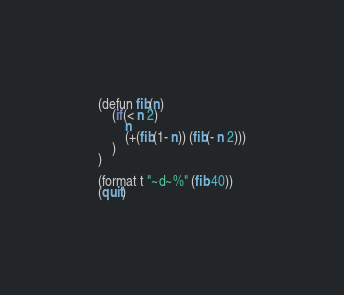Convert code to text. <code><loc_0><loc_0><loc_500><loc_500><_Lisp_>(defun fib(n)
	(if(< n 2)
		n
		(+(fib(1- n)) (fib(- n 2)))
	)
)

(format t "~d~%" (fib 40))
(quit)
</code> 